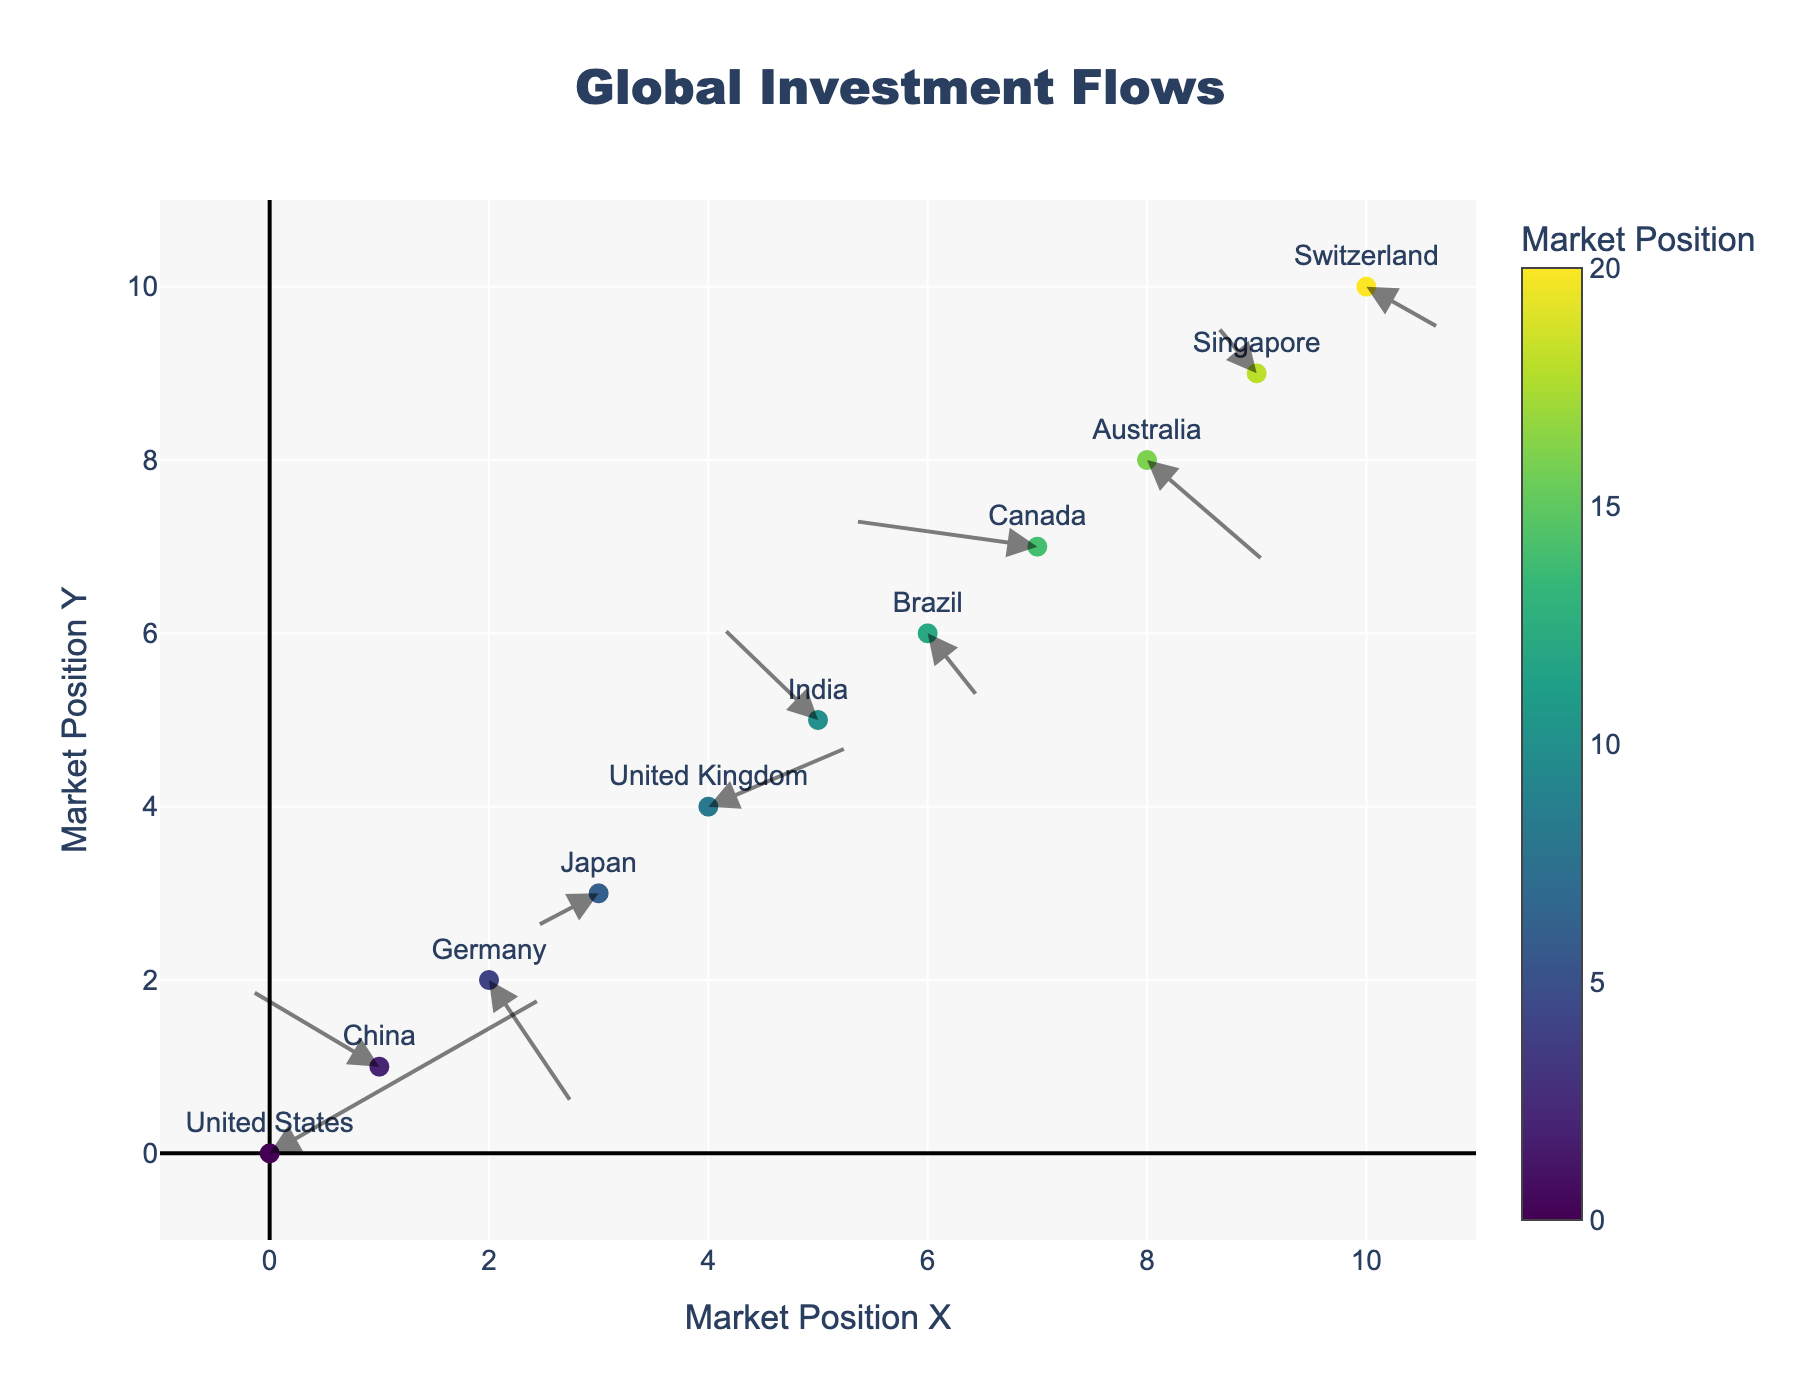What is the title of the plot? The title of the plot is displayed at the top and usually provides a brief description of the figure. In this case, it is "Global Investment Flows."
Answer: Global Investment Flows Which axis represents the Market Position X? The X-axis represents Market Position X, which is clearly labeled at the bottom of the figure.
Answer: X-axis How many countries are represented in the plot? By counting the total number of labeled points in the scatter plot, we can determine the number of countries represented. There are 11 labeled points in the plot.
Answer: 11 Which country has the largest positive U value, and what is its value? The U values represent the horizontal component of the vector field. By examining the data, the United States has the largest positive U value at 2.5.
Answer: United States, 2.5 Which country is positioned at (3, 3) and what direction does its investment flow point? By looking at the coordinates (3, 3) on the plot, the country positioned there is Japan. The vector arrow points toward the direction based on the U and V values. For Japan, the arrow points to (3 - 0.6, 3 - 0.4) which is the southwest direction.
Answer: Japan, southwest Compare the capital movement direction between China and Germany. China's vector arrow points to (-0.2, 1.9) which is primarily west, while Germany's vector arrow points to (2.8, 0.5) which is southeast. This comparison shows that China's capital flows westward while Germany's flows southeastward.
Answer: China: west, Germany: southeast Which country has the arrow pointing to the northeast and what are its coordinates? An arrow pointing northeast would have positive U and V values. The United Kingdom (4, 4) has its arrow pointing northeast with U = 1.3 and V = 0.7.
Answer: United Kingdom, (4, 4) What is the average of the X coordinates of all countries? By summing up all X coordinates (0, 1, 2, 3, 4, 5, 6, 7, 8, 9, 10) and dividing by the number of countries, we get the average. The sum is 55 and there are 11 countries. Average = 55 / 11 = 5
Answer: 5 How does the investment flow direction for Brazil compare to that of Australia in terms of investment inflow to outflow? For Brazil (6, 6), the U value is 0.5 (eastward) and V is -0.8 (southward), indicating an outflow to the southeast. Australia (8, 8) has U = 1.1 (eastward) and V = -1.2 (southward), indicating an outflow to the southeast as well. Both countries have investment flows pointing southeast.
Answer: Brazil and Australia: southeast 